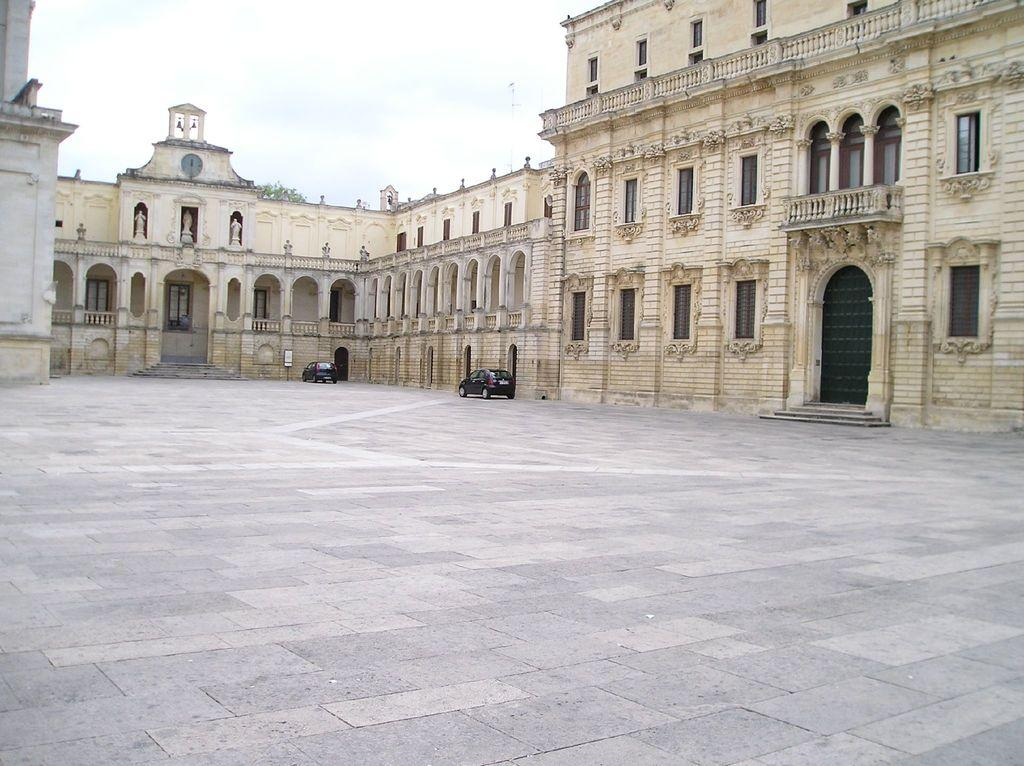What type of location is depicted in the image? The image shows a place with multiple entries and windows. Are there any vehicles visible in the image? Yes, there are two cars in the image. What is the condition of the sky in the image? The sky is clear in the image. Can you see a tail hanging from the window in the image? There is no tail hanging from the window in the image. Is there a cord visible connecting the two cars in the image? There is no cord connecting the two cars in the image. 